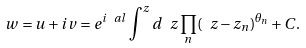<formula> <loc_0><loc_0><loc_500><loc_500>w = u + i v = e ^ { i \ a l } \int ^ { z } d \ z \prod _ { n } ( \ z - z _ { n } ) ^ { \theta _ { n } } + C .</formula> 